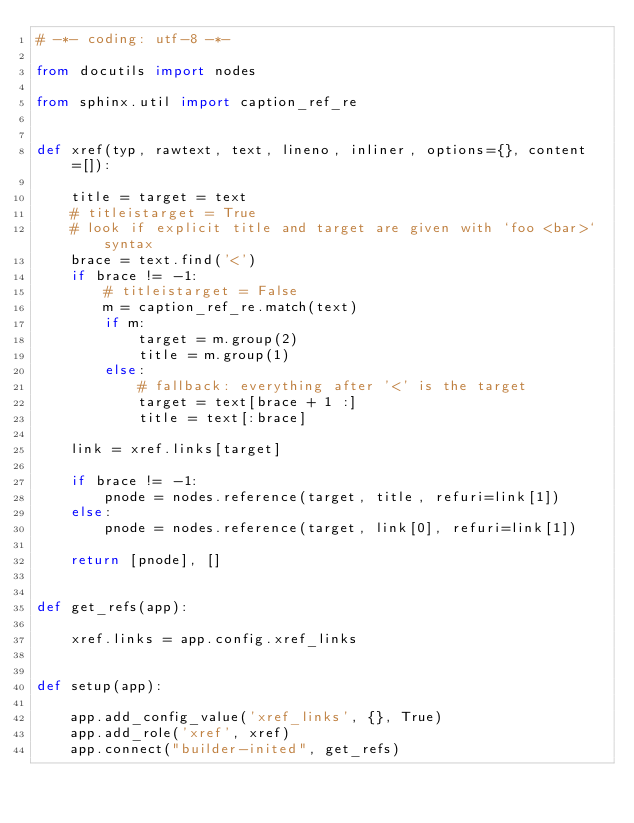<code> <loc_0><loc_0><loc_500><loc_500><_Python_># -*- coding: utf-8 -*-

from docutils import nodes

from sphinx.util import caption_ref_re


def xref(typ, rawtext, text, lineno, inliner, options={}, content=[]):

    title = target = text
    # titleistarget = True
    # look if explicit title and target are given with `foo <bar>` syntax
    brace = text.find('<')
    if brace != -1:
        # titleistarget = False
        m = caption_ref_re.match(text)
        if m:
            target = m.group(2)
            title = m.group(1)
        else:
            # fallback: everything after '<' is the target
            target = text[brace + 1 :]
            title = text[:brace]

    link = xref.links[target]

    if brace != -1:
        pnode = nodes.reference(target, title, refuri=link[1])
    else:
        pnode = nodes.reference(target, link[0], refuri=link[1])

    return [pnode], []


def get_refs(app):

    xref.links = app.config.xref_links


def setup(app):

    app.add_config_value('xref_links', {}, True)
    app.add_role('xref', xref)
    app.connect("builder-inited", get_refs)
</code> 